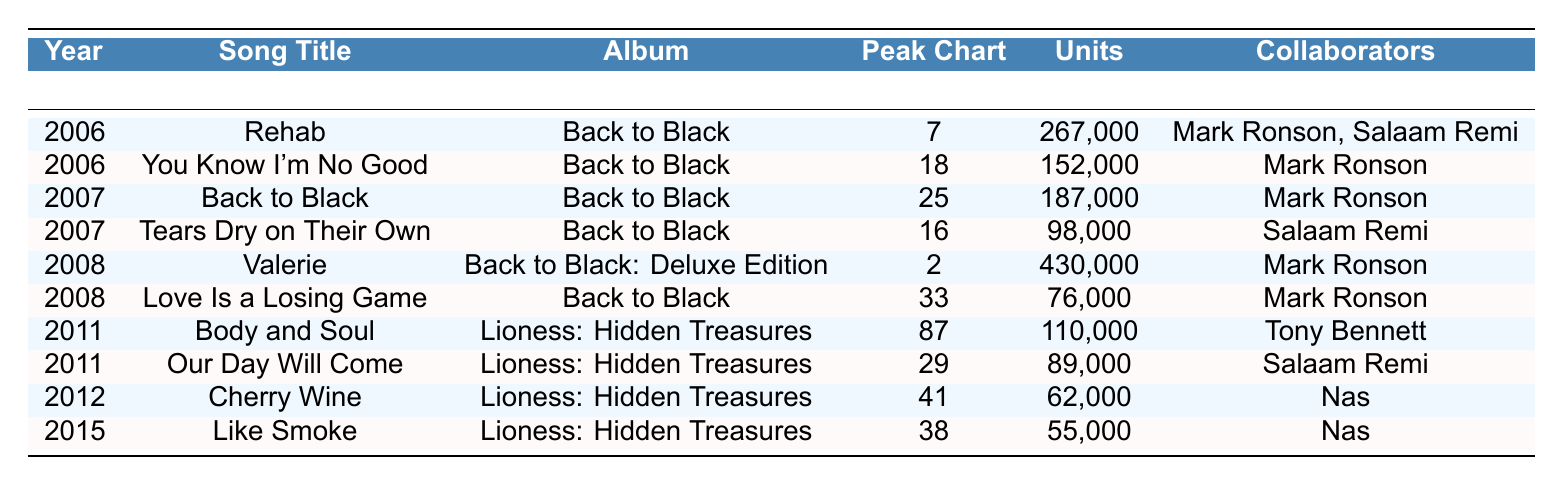What was the song with the highest units sold? The table shows the number of units sold for each song. The song "Valerie" sold the most units at 430,000.
Answer: Valerie In which year was "Rehab" released? The table lists "Rehab" under the year 2006.
Answer: 2006 Which song had the lowest peak chart position? Looking at the "Peak Chart Position" column, "Body and Soul" has the lowest position at 87.
Answer: Body and Soul What is the total units sold for all the songs in 2008? For 2008, the songs are "Valerie" (430,000) and "Love Is a Losing Game" (76,000). The total is 430,000 + 76,000 = 506,000.
Answer: 506,000 Did any song from the album "Lioness: Hidden Treasures" reach a peak chart position higher than 29? Only "Body and Soul" (87) and "Our Day Will Come" (29) are from that album. Neither reached a higher position than 29.
Answer: No Which album had the highest-selling song? The song "Valerie" from "Back to Black: Deluxe Edition" sold the most units (430,000), which is higher than any from "Lioness: Hidden Treasures."
Answer: Back to Black: Deluxe Edition How many songs reached a peak position below 20? "Rehab" (7), "Valerie" (2), and "Tears Dry on Their Own" (16) all peaked below 20, totaling three songs.
Answer: 3 What is the average units sold for the songs in 2011? The songs in 2011 are "Body and Soul" (110,000) and "Our Day Will Come" (89,000). Average = (110,000 + 89,000) / 2 = 99,500.
Answer: 99,500 What is the difference in units sold between "Cherry Wine" and "Like Smoke"? "Cherry Wine" sold 62,000, and "Like Smoke" sold 55,000. The difference is 62,000 - 55,000 = 7,000.
Answer: 7,000 Which collaborator worked on the most songs listed in the table? "Mark Ronson" collaborated on four songs: "Rehab," "You Know I'm No Good," "Back to Black," and "Valerie." No one else has more than two.
Answer: Mark Ronson 